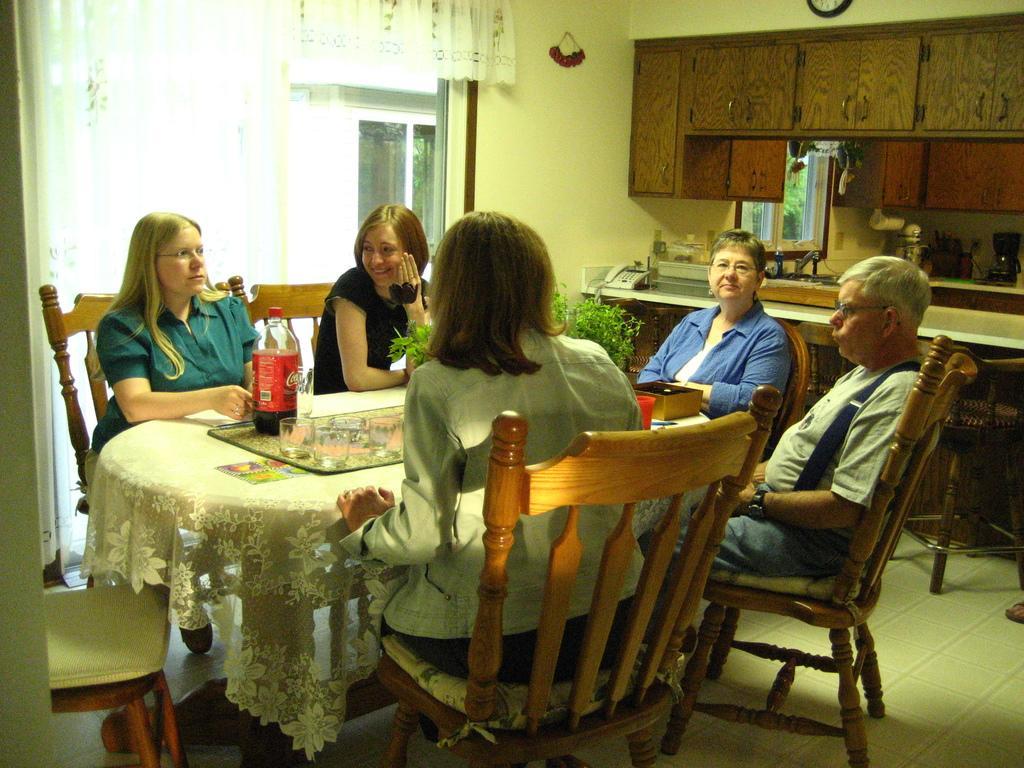Describe this image in one or two sentences. Here there are five people sitting on the chairs in between the table and on table we have some glasses and a coke bottle and beside them there is a shelf and a small plant. 